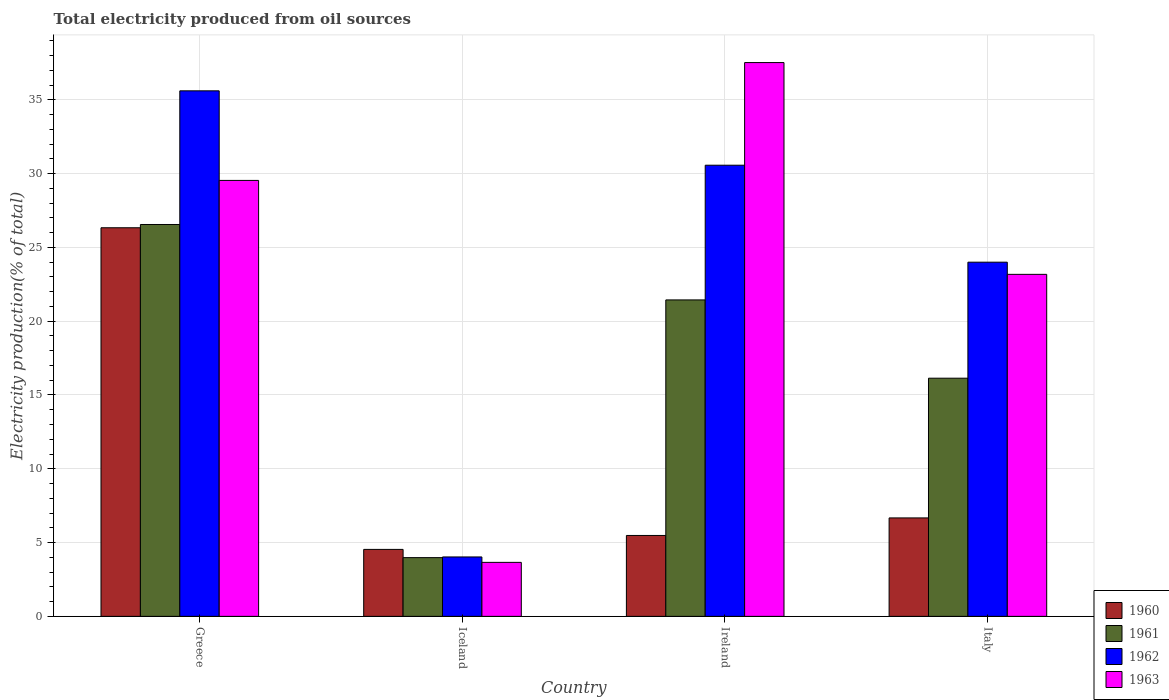How many different coloured bars are there?
Your answer should be compact. 4. Are the number of bars on each tick of the X-axis equal?
Your answer should be compact. Yes. What is the label of the 4th group of bars from the left?
Your answer should be compact. Italy. In how many cases, is the number of bars for a given country not equal to the number of legend labels?
Offer a very short reply. 0. What is the total electricity produced in 1963 in Ireland?
Your answer should be compact. 37.53. Across all countries, what is the maximum total electricity produced in 1961?
Offer a terse response. 26.55. Across all countries, what is the minimum total electricity produced in 1962?
Provide a succinct answer. 4.03. In which country was the total electricity produced in 1963 maximum?
Give a very brief answer. Ireland. In which country was the total electricity produced in 1962 minimum?
Keep it short and to the point. Iceland. What is the total total electricity produced in 1960 in the graph?
Make the answer very short. 43.02. What is the difference between the total electricity produced in 1960 in Greece and that in Italy?
Ensure brevity in your answer.  19.66. What is the difference between the total electricity produced in 1960 in Greece and the total electricity produced in 1961 in Iceland?
Give a very brief answer. 22.35. What is the average total electricity produced in 1960 per country?
Make the answer very short. 10.76. What is the difference between the total electricity produced of/in 1962 and total electricity produced of/in 1963 in Ireland?
Give a very brief answer. -6.95. What is the ratio of the total electricity produced in 1963 in Greece to that in Italy?
Provide a short and direct response. 1.27. What is the difference between the highest and the second highest total electricity produced in 1962?
Provide a short and direct response. 5.04. What is the difference between the highest and the lowest total electricity produced in 1961?
Provide a short and direct response. 22.57. In how many countries, is the total electricity produced in 1962 greater than the average total electricity produced in 1962 taken over all countries?
Offer a very short reply. 3. Is the sum of the total electricity produced in 1963 in Greece and Italy greater than the maximum total electricity produced in 1961 across all countries?
Your response must be concise. Yes. Is it the case that in every country, the sum of the total electricity produced in 1963 and total electricity produced in 1962 is greater than the sum of total electricity produced in 1960 and total electricity produced in 1961?
Your answer should be very brief. No. What does the 3rd bar from the right in Greece represents?
Give a very brief answer. 1961. What is the difference between two consecutive major ticks on the Y-axis?
Your answer should be very brief. 5. Are the values on the major ticks of Y-axis written in scientific E-notation?
Keep it short and to the point. No. Does the graph contain any zero values?
Keep it short and to the point. No. Does the graph contain grids?
Provide a succinct answer. Yes. Where does the legend appear in the graph?
Keep it short and to the point. Bottom right. What is the title of the graph?
Ensure brevity in your answer.  Total electricity produced from oil sources. What is the Electricity production(% of total) of 1960 in Greece?
Provide a succinct answer. 26.33. What is the Electricity production(% of total) in 1961 in Greece?
Provide a succinct answer. 26.55. What is the Electricity production(% of total) of 1962 in Greece?
Your response must be concise. 35.61. What is the Electricity production(% of total) of 1963 in Greece?
Keep it short and to the point. 29.54. What is the Electricity production(% of total) in 1960 in Iceland?
Offer a very short reply. 4.54. What is the Electricity production(% of total) of 1961 in Iceland?
Ensure brevity in your answer.  3.98. What is the Electricity production(% of total) in 1962 in Iceland?
Offer a very short reply. 4.03. What is the Electricity production(% of total) in 1963 in Iceland?
Ensure brevity in your answer.  3.66. What is the Electricity production(% of total) of 1960 in Ireland?
Your response must be concise. 5.48. What is the Electricity production(% of total) in 1961 in Ireland?
Your answer should be very brief. 21.44. What is the Electricity production(% of total) of 1962 in Ireland?
Provide a succinct answer. 30.57. What is the Electricity production(% of total) of 1963 in Ireland?
Ensure brevity in your answer.  37.53. What is the Electricity production(% of total) in 1960 in Italy?
Provide a succinct answer. 6.67. What is the Electricity production(% of total) in 1961 in Italy?
Provide a succinct answer. 16.14. What is the Electricity production(% of total) in 1962 in Italy?
Make the answer very short. 24. What is the Electricity production(% of total) in 1963 in Italy?
Your answer should be compact. 23.17. Across all countries, what is the maximum Electricity production(% of total) in 1960?
Provide a succinct answer. 26.33. Across all countries, what is the maximum Electricity production(% of total) in 1961?
Your response must be concise. 26.55. Across all countries, what is the maximum Electricity production(% of total) of 1962?
Your answer should be compact. 35.61. Across all countries, what is the maximum Electricity production(% of total) in 1963?
Offer a very short reply. 37.53. Across all countries, what is the minimum Electricity production(% of total) of 1960?
Offer a very short reply. 4.54. Across all countries, what is the minimum Electricity production(% of total) of 1961?
Provide a short and direct response. 3.98. Across all countries, what is the minimum Electricity production(% of total) in 1962?
Give a very brief answer. 4.03. Across all countries, what is the minimum Electricity production(% of total) in 1963?
Make the answer very short. 3.66. What is the total Electricity production(% of total) in 1960 in the graph?
Make the answer very short. 43.02. What is the total Electricity production(% of total) of 1961 in the graph?
Your response must be concise. 68.12. What is the total Electricity production(% of total) in 1962 in the graph?
Your answer should be very brief. 94.21. What is the total Electricity production(% of total) in 1963 in the graph?
Your answer should be very brief. 93.9. What is the difference between the Electricity production(% of total) of 1960 in Greece and that in Iceland?
Make the answer very short. 21.79. What is the difference between the Electricity production(% of total) of 1961 in Greece and that in Iceland?
Ensure brevity in your answer.  22.57. What is the difference between the Electricity production(% of total) in 1962 in Greece and that in Iceland?
Your response must be concise. 31.58. What is the difference between the Electricity production(% of total) of 1963 in Greece and that in Iceland?
Give a very brief answer. 25.88. What is the difference between the Electricity production(% of total) in 1960 in Greece and that in Ireland?
Make the answer very short. 20.85. What is the difference between the Electricity production(% of total) in 1961 in Greece and that in Ireland?
Make the answer very short. 5.11. What is the difference between the Electricity production(% of total) in 1962 in Greece and that in Ireland?
Provide a succinct answer. 5.04. What is the difference between the Electricity production(% of total) of 1963 in Greece and that in Ireland?
Give a very brief answer. -7.99. What is the difference between the Electricity production(% of total) of 1960 in Greece and that in Italy?
Your answer should be compact. 19.66. What is the difference between the Electricity production(% of total) in 1961 in Greece and that in Italy?
Offer a terse response. 10.42. What is the difference between the Electricity production(% of total) of 1962 in Greece and that in Italy?
Provide a succinct answer. 11.61. What is the difference between the Electricity production(% of total) in 1963 in Greece and that in Italy?
Provide a succinct answer. 6.37. What is the difference between the Electricity production(% of total) of 1960 in Iceland and that in Ireland?
Give a very brief answer. -0.94. What is the difference between the Electricity production(% of total) of 1961 in Iceland and that in Ireland?
Provide a succinct answer. -17.46. What is the difference between the Electricity production(% of total) in 1962 in Iceland and that in Ireland?
Provide a succinct answer. -26.55. What is the difference between the Electricity production(% of total) of 1963 in Iceland and that in Ireland?
Provide a short and direct response. -33.87. What is the difference between the Electricity production(% of total) in 1960 in Iceland and that in Italy?
Offer a very short reply. -2.13. What is the difference between the Electricity production(% of total) in 1961 in Iceland and that in Italy?
Keep it short and to the point. -12.16. What is the difference between the Electricity production(% of total) in 1962 in Iceland and that in Italy?
Keep it short and to the point. -19.97. What is the difference between the Electricity production(% of total) in 1963 in Iceland and that in Italy?
Ensure brevity in your answer.  -19.52. What is the difference between the Electricity production(% of total) of 1960 in Ireland and that in Italy?
Offer a terse response. -1.19. What is the difference between the Electricity production(% of total) of 1961 in Ireland and that in Italy?
Provide a short and direct response. 5.3. What is the difference between the Electricity production(% of total) in 1962 in Ireland and that in Italy?
Your response must be concise. 6.57. What is the difference between the Electricity production(% of total) of 1963 in Ireland and that in Italy?
Make the answer very short. 14.35. What is the difference between the Electricity production(% of total) of 1960 in Greece and the Electricity production(% of total) of 1961 in Iceland?
Give a very brief answer. 22.35. What is the difference between the Electricity production(% of total) in 1960 in Greece and the Electricity production(% of total) in 1962 in Iceland?
Keep it short and to the point. 22.31. What is the difference between the Electricity production(% of total) of 1960 in Greece and the Electricity production(% of total) of 1963 in Iceland?
Provide a succinct answer. 22.67. What is the difference between the Electricity production(% of total) of 1961 in Greece and the Electricity production(% of total) of 1962 in Iceland?
Your response must be concise. 22.53. What is the difference between the Electricity production(% of total) of 1961 in Greece and the Electricity production(% of total) of 1963 in Iceland?
Offer a very short reply. 22.9. What is the difference between the Electricity production(% of total) of 1962 in Greece and the Electricity production(% of total) of 1963 in Iceland?
Provide a short and direct response. 31.95. What is the difference between the Electricity production(% of total) of 1960 in Greece and the Electricity production(% of total) of 1961 in Ireland?
Give a very brief answer. 4.89. What is the difference between the Electricity production(% of total) of 1960 in Greece and the Electricity production(% of total) of 1962 in Ireland?
Your answer should be very brief. -4.24. What is the difference between the Electricity production(% of total) in 1960 in Greece and the Electricity production(% of total) in 1963 in Ireland?
Your answer should be compact. -11.19. What is the difference between the Electricity production(% of total) of 1961 in Greece and the Electricity production(% of total) of 1962 in Ireland?
Your answer should be compact. -4.02. What is the difference between the Electricity production(% of total) in 1961 in Greece and the Electricity production(% of total) in 1963 in Ireland?
Provide a succinct answer. -10.97. What is the difference between the Electricity production(% of total) in 1962 in Greece and the Electricity production(% of total) in 1963 in Ireland?
Make the answer very short. -1.92. What is the difference between the Electricity production(% of total) of 1960 in Greece and the Electricity production(% of total) of 1961 in Italy?
Provide a short and direct response. 10.19. What is the difference between the Electricity production(% of total) of 1960 in Greece and the Electricity production(% of total) of 1962 in Italy?
Offer a terse response. 2.33. What is the difference between the Electricity production(% of total) of 1960 in Greece and the Electricity production(% of total) of 1963 in Italy?
Your answer should be very brief. 3.16. What is the difference between the Electricity production(% of total) of 1961 in Greece and the Electricity production(% of total) of 1962 in Italy?
Your answer should be compact. 2.55. What is the difference between the Electricity production(% of total) of 1961 in Greece and the Electricity production(% of total) of 1963 in Italy?
Provide a short and direct response. 3.38. What is the difference between the Electricity production(% of total) of 1962 in Greece and the Electricity production(% of total) of 1963 in Italy?
Make the answer very short. 12.44. What is the difference between the Electricity production(% of total) in 1960 in Iceland and the Electricity production(% of total) in 1961 in Ireland?
Ensure brevity in your answer.  -16.91. What is the difference between the Electricity production(% of total) of 1960 in Iceland and the Electricity production(% of total) of 1962 in Ireland?
Make the answer very short. -26.03. What is the difference between the Electricity production(% of total) of 1960 in Iceland and the Electricity production(% of total) of 1963 in Ireland?
Offer a terse response. -32.99. What is the difference between the Electricity production(% of total) in 1961 in Iceland and the Electricity production(% of total) in 1962 in Ireland?
Offer a terse response. -26.59. What is the difference between the Electricity production(% of total) of 1961 in Iceland and the Electricity production(% of total) of 1963 in Ireland?
Your answer should be compact. -33.55. What is the difference between the Electricity production(% of total) of 1962 in Iceland and the Electricity production(% of total) of 1963 in Ireland?
Provide a succinct answer. -33.5. What is the difference between the Electricity production(% of total) in 1960 in Iceland and the Electricity production(% of total) in 1961 in Italy?
Your response must be concise. -11.6. What is the difference between the Electricity production(% of total) in 1960 in Iceland and the Electricity production(% of total) in 1962 in Italy?
Ensure brevity in your answer.  -19.46. What is the difference between the Electricity production(% of total) of 1960 in Iceland and the Electricity production(% of total) of 1963 in Italy?
Ensure brevity in your answer.  -18.64. What is the difference between the Electricity production(% of total) in 1961 in Iceland and the Electricity production(% of total) in 1962 in Italy?
Offer a terse response. -20.02. What is the difference between the Electricity production(% of total) of 1961 in Iceland and the Electricity production(% of total) of 1963 in Italy?
Make the answer very short. -19.19. What is the difference between the Electricity production(% of total) in 1962 in Iceland and the Electricity production(% of total) in 1963 in Italy?
Offer a terse response. -19.15. What is the difference between the Electricity production(% of total) of 1960 in Ireland and the Electricity production(% of total) of 1961 in Italy?
Ensure brevity in your answer.  -10.66. What is the difference between the Electricity production(% of total) of 1960 in Ireland and the Electricity production(% of total) of 1962 in Italy?
Give a very brief answer. -18.52. What is the difference between the Electricity production(% of total) in 1960 in Ireland and the Electricity production(% of total) in 1963 in Italy?
Offer a terse response. -17.69. What is the difference between the Electricity production(% of total) of 1961 in Ireland and the Electricity production(% of total) of 1962 in Italy?
Ensure brevity in your answer.  -2.56. What is the difference between the Electricity production(% of total) in 1961 in Ireland and the Electricity production(% of total) in 1963 in Italy?
Give a very brief answer. -1.73. What is the difference between the Electricity production(% of total) in 1962 in Ireland and the Electricity production(% of total) in 1963 in Italy?
Your answer should be very brief. 7.4. What is the average Electricity production(% of total) in 1960 per country?
Make the answer very short. 10.76. What is the average Electricity production(% of total) in 1961 per country?
Your answer should be very brief. 17.03. What is the average Electricity production(% of total) of 1962 per country?
Give a very brief answer. 23.55. What is the average Electricity production(% of total) of 1963 per country?
Provide a succinct answer. 23.47. What is the difference between the Electricity production(% of total) in 1960 and Electricity production(% of total) in 1961 in Greece?
Provide a succinct answer. -0.22. What is the difference between the Electricity production(% of total) in 1960 and Electricity production(% of total) in 1962 in Greece?
Provide a short and direct response. -9.28. What is the difference between the Electricity production(% of total) of 1960 and Electricity production(% of total) of 1963 in Greece?
Make the answer very short. -3.21. What is the difference between the Electricity production(% of total) in 1961 and Electricity production(% of total) in 1962 in Greece?
Make the answer very short. -9.06. What is the difference between the Electricity production(% of total) of 1961 and Electricity production(% of total) of 1963 in Greece?
Provide a succinct answer. -2.99. What is the difference between the Electricity production(% of total) of 1962 and Electricity production(% of total) of 1963 in Greece?
Make the answer very short. 6.07. What is the difference between the Electricity production(% of total) of 1960 and Electricity production(% of total) of 1961 in Iceland?
Offer a very short reply. 0.56. What is the difference between the Electricity production(% of total) of 1960 and Electricity production(% of total) of 1962 in Iceland?
Keep it short and to the point. 0.51. What is the difference between the Electricity production(% of total) of 1960 and Electricity production(% of total) of 1963 in Iceland?
Your response must be concise. 0.88. What is the difference between the Electricity production(% of total) of 1961 and Electricity production(% of total) of 1962 in Iceland?
Provide a short and direct response. -0.05. What is the difference between the Electricity production(% of total) in 1961 and Electricity production(% of total) in 1963 in Iceland?
Your answer should be compact. 0.32. What is the difference between the Electricity production(% of total) in 1962 and Electricity production(% of total) in 1963 in Iceland?
Offer a very short reply. 0.37. What is the difference between the Electricity production(% of total) of 1960 and Electricity production(% of total) of 1961 in Ireland?
Offer a very short reply. -15.96. What is the difference between the Electricity production(% of total) in 1960 and Electricity production(% of total) in 1962 in Ireland?
Give a very brief answer. -25.09. What is the difference between the Electricity production(% of total) in 1960 and Electricity production(% of total) in 1963 in Ireland?
Your response must be concise. -32.04. What is the difference between the Electricity production(% of total) of 1961 and Electricity production(% of total) of 1962 in Ireland?
Your response must be concise. -9.13. What is the difference between the Electricity production(% of total) of 1961 and Electricity production(% of total) of 1963 in Ireland?
Offer a terse response. -16.08. What is the difference between the Electricity production(% of total) in 1962 and Electricity production(% of total) in 1963 in Ireland?
Give a very brief answer. -6.95. What is the difference between the Electricity production(% of total) in 1960 and Electricity production(% of total) in 1961 in Italy?
Provide a short and direct response. -9.47. What is the difference between the Electricity production(% of total) of 1960 and Electricity production(% of total) of 1962 in Italy?
Make the answer very short. -17.33. What is the difference between the Electricity production(% of total) of 1960 and Electricity production(% of total) of 1963 in Italy?
Give a very brief answer. -16.5. What is the difference between the Electricity production(% of total) in 1961 and Electricity production(% of total) in 1962 in Italy?
Provide a short and direct response. -7.86. What is the difference between the Electricity production(% of total) of 1961 and Electricity production(% of total) of 1963 in Italy?
Ensure brevity in your answer.  -7.04. What is the difference between the Electricity production(% of total) in 1962 and Electricity production(% of total) in 1963 in Italy?
Keep it short and to the point. 0.83. What is the ratio of the Electricity production(% of total) in 1960 in Greece to that in Iceland?
Offer a terse response. 5.8. What is the ratio of the Electricity production(% of total) of 1961 in Greece to that in Iceland?
Provide a short and direct response. 6.67. What is the ratio of the Electricity production(% of total) in 1962 in Greece to that in Iceland?
Your answer should be compact. 8.85. What is the ratio of the Electricity production(% of total) in 1963 in Greece to that in Iceland?
Provide a succinct answer. 8.07. What is the ratio of the Electricity production(% of total) in 1960 in Greece to that in Ireland?
Your response must be concise. 4.8. What is the ratio of the Electricity production(% of total) of 1961 in Greece to that in Ireland?
Provide a short and direct response. 1.24. What is the ratio of the Electricity production(% of total) in 1962 in Greece to that in Ireland?
Your answer should be compact. 1.16. What is the ratio of the Electricity production(% of total) of 1963 in Greece to that in Ireland?
Provide a succinct answer. 0.79. What is the ratio of the Electricity production(% of total) in 1960 in Greece to that in Italy?
Ensure brevity in your answer.  3.95. What is the ratio of the Electricity production(% of total) of 1961 in Greece to that in Italy?
Your answer should be compact. 1.65. What is the ratio of the Electricity production(% of total) in 1962 in Greece to that in Italy?
Your answer should be very brief. 1.48. What is the ratio of the Electricity production(% of total) in 1963 in Greece to that in Italy?
Your answer should be compact. 1.27. What is the ratio of the Electricity production(% of total) in 1960 in Iceland to that in Ireland?
Make the answer very short. 0.83. What is the ratio of the Electricity production(% of total) in 1961 in Iceland to that in Ireland?
Provide a short and direct response. 0.19. What is the ratio of the Electricity production(% of total) of 1962 in Iceland to that in Ireland?
Your answer should be very brief. 0.13. What is the ratio of the Electricity production(% of total) of 1963 in Iceland to that in Ireland?
Your answer should be very brief. 0.1. What is the ratio of the Electricity production(% of total) in 1960 in Iceland to that in Italy?
Give a very brief answer. 0.68. What is the ratio of the Electricity production(% of total) in 1961 in Iceland to that in Italy?
Ensure brevity in your answer.  0.25. What is the ratio of the Electricity production(% of total) of 1962 in Iceland to that in Italy?
Provide a succinct answer. 0.17. What is the ratio of the Electricity production(% of total) of 1963 in Iceland to that in Italy?
Keep it short and to the point. 0.16. What is the ratio of the Electricity production(% of total) of 1960 in Ireland to that in Italy?
Keep it short and to the point. 0.82. What is the ratio of the Electricity production(% of total) of 1961 in Ireland to that in Italy?
Ensure brevity in your answer.  1.33. What is the ratio of the Electricity production(% of total) in 1962 in Ireland to that in Italy?
Your answer should be compact. 1.27. What is the ratio of the Electricity production(% of total) of 1963 in Ireland to that in Italy?
Your answer should be very brief. 1.62. What is the difference between the highest and the second highest Electricity production(% of total) of 1960?
Ensure brevity in your answer.  19.66. What is the difference between the highest and the second highest Electricity production(% of total) in 1961?
Keep it short and to the point. 5.11. What is the difference between the highest and the second highest Electricity production(% of total) of 1962?
Ensure brevity in your answer.  5.04. What is the difference between the highest and the second highest Electricity production(% of total) of 1963?
Offer a terse response. 7.99. What is the difference between the highest and the lowest Electricity production(% of total) in 1960?
Keep it short and to the point. 21.79. What is the difference between the highest and the lowest Electricity production(% of total) of 1961?
Your answer should be very brief. 22.57. What is the difference between the highest and the lowest Electricity production(% of total) of 1962?
Provide a succinct answer. 31.58. What is the difference between the highest and the lowest Electricity production(% of total) in 1963?
Give a very brief answer. 33.87. 